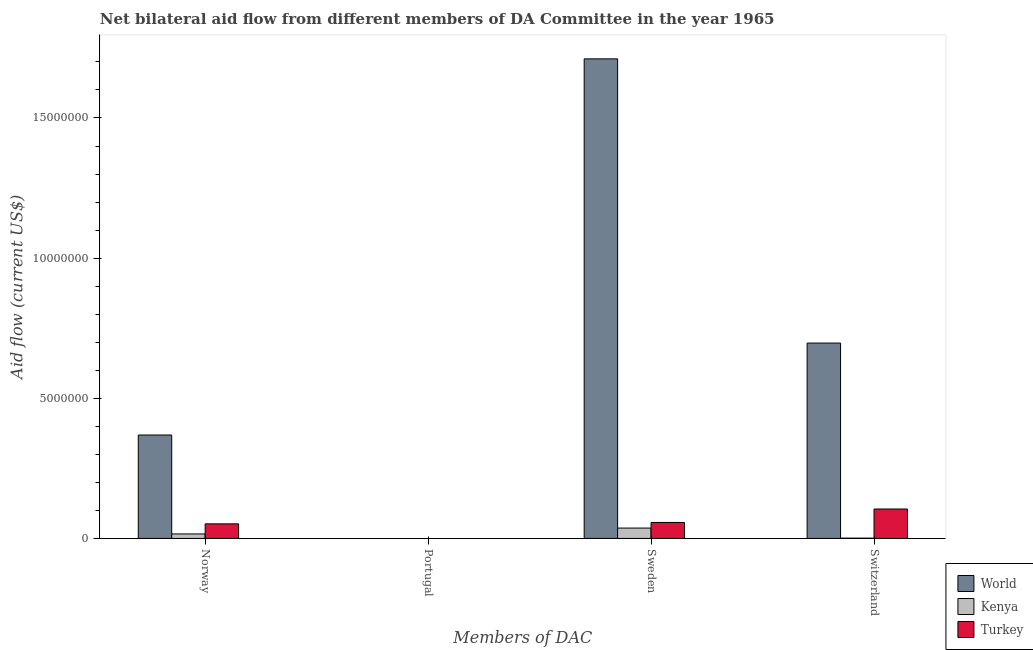How many different coloured bars are there?
Offer a terse response. 3. Are the number of bars per tick equal to the number of legend labels?
Provide a succinct answer. No. How many bars are there on the 1st tick from the left?
Provide a short and direct response. 3. How many bars are there on the 1st tick from the right?
Your response must be concise. 3. What is the label of the 2nd group of bars from the left?
Your answer should be very brief. Portugal. What is the amount of aid given by portugal in World?
Give a very brief answer. 0. Across all countries, what is the maximum amount of aid given by norway?
Your answer should be compact. 3.69e+06. Across all countries, what is the minimum amount of aid given by norway?
Your answer should be very brief. 1.60e+05. What is the total amount of aid given by sweden in the graph?
Offer a terse response. 1.80e+07. What is the difference between the amount of aid given by norway in World and that in Turkey?
Provide a short and direct response. 3.17e+06. What is the difference between the amount of aid given by portugal in Turkey and the amount of aid given by switzerland in World?
Provide a succinct answer. -6.97e+06. What is the average amount of aid given by portugal per country?
Your answer should be very brief. 0. What is the difference between the amount of aid given by norway and amount of aid given by sweden in Turkey?
Your answer should be very brief. -5.00e+04. In how many countries, is the amount of aid given by portugal greater than 9000000 US$?
Offer a terse response. 0. What is the ratio of the amount of aid given by switzerland in Turkey to that in World?
Make the answer very short. 0.15. Is the difference between the amount of aid given by sweden in Kenya and Turkey greater than the difference between the amount of aid given by switzerland in Kenya and Turkey?
Make the answer very short. Yes. What is the difference between the highest and the second highest amount of aid given by norway?
Your answer should be compact. 3.17e+06. What is the difference between the highest and the lowest amount of aid given by norway?
Keep it short and to the point. 3.53e+06. Is it the case that in every country, the sum of the amount of aid given by portugal and amount of aid given by sweden is greater than the sum of amount of aid given by norway and amount of aid given by switzerland?
Make the answer very short. No. How many bars are there?
Offer a very short reply. 12. Are the values on the major ticks of Y-axis written in scientific E-notation?
Provide a short and direct response. No. What is the title of the graph?
Make the answer very short. Net bilateral aid flow from different members of DA Committee in the year 1965. What is the label or title of the X-axis?
Your response must be concise. Members of DAC. What is the Aid flow (current US$) in World in Norway?
Provide a succinct answer. 3.69e+06. What is the Aid flow (current US$) in Turkey in Norway?
Give a very brief answer. 5.20e+05. What is the Aid flow (current US$) in World in Portugal?
Your response must be concise. Nan. What is the Aid flow (current US$) in Kenya in Portugal?
Offer a terse response. Nan. What is the Aid flow (current US$) in Turkey in Portugal?
Your response must be concise. Nan. What is the Aid flow (current US$) in World in Sweden?
Ensure brevity in your answer.  1.71e+07. What is the Aid flow (current US$) in Kenya in Sweden?
Keep it short and to the point. 3.70e+05. What is the Aid flow (current US$) in Turkey in Sweden?
Your answer should be very brief. 5.70e+05. What is the Aid flow (current US$) of World in Switzerland?
Ensure brevity in your answer.  6.97e+06. What is the Aid flow (current US$) of Kenya in Switzerland?
Make the answer very short. 10000. What is the Aid flow (current US$) of Turkey in Switzerland?
Offer a terse response. 1.05e+06. Across all Members of DAC, what is the maximum Aid flow (current US$) of World?
Your answer should be compact. 1.71e+07. Across all Members of DAC, what is the maximum Aid flow (current US$) of Turkey?
Provide a succinct answer. 1.05e+06. Across all Members of DAC, what is the minimum Aid flow (current US$) in World?
Keep it short and to the point. 3.69e+06. Across all Members of DAC, what is the minimum Aid flow (current US$) of Turkey?
Offer a terse response. 5.20e+05. What is the total Aid flow (current US$) in World in the graph?
Offer a terse response. 2.78e+07. What is the total Aid flow (current US$) in Kenya in the graph?
Offer a very short reply. 5.40e+05. What is the total Aid flow (current US$) of Turkey in the graph?
Your answer should be very brief. 2.14e+06. What is the difference between the Aid flow (current US$) in World in Norway and that in Portugal?
Offer a very short reply. Nan. What is the difference between the Aid flow (current US$) in Kenya in Norway and that in Portugal?
Ensure brevity in your answer.  Nan. What is the difference between the Aid flow (current US$) in Turkey in Norway and that in Portugal?
Your response must be concise. Nan. What is the difference between the Aid flow (current US$) in World in Norway and that in Sweden?
Give a very brief answer. -1.34e+07. What is the difference between the Aid flow (current US$) of World in Norway and that in Switzerland?
Offer a terse response. -3.28e+06. What is the difference between the Aid flow (current US$) in Kenya in Norway and that in Switzerland?
Keep it short and to the point. 1.50e+05. What is the difference between the Aid flow (current US$) in Turkey in Norway and that in Switzerland?
Your answer should be compact. -5.30e+05. What is the difference between the Aid flow (current US$) in World in Portugal and that in Sweden?
Give a very brief answer. Nan. What is the difference between the Aid flow (current US$) in Kenya in Portugal and that in Sweden?
Your answer should be very brief. Nan. What is the difference between the Aid flow (current US$) in Turkey in Portugal and that in Sweden?
Offer a terse response. Nan. What is the difference between the Aid flow (current US$) of World in Portugal and that in Switzerland?
Give a very brief answer. Nan. What is the difference between the Aid flow (current US$) of Kenya in Portugal and that in Switzerland?
Offer a very short reply. Nan. What is the difference between the Aid flow (current US$) of Turkey in Portugal and that in Switzerland?
Provide a succinct answer. Nan. What is the difference between the Aid flow (current US$) of World in Sweden and that in Switzerland?
Ensure brevity in your answer.  1.01e+07. What is the difference between the Aid flow (current US$) of Kenya in Sweden and that in Switzerland?
Ensure brevity in your answer.  3.60e+05. What is the difference between the Aid flow (current US$) of Turkey in Sweden and that in Switzerland?
Offer a very short reply. -4.80e+05. What is the difference between the Aid flow (current US$) of World in Norway and the Aid flow (current US$) of Kenya in Portugal?
Offer a very short reply. Nan. What is the difference between the Aid flow (current US$) in World in Norway and the Aid flow (current US$) in Turkey in Portugal?
Ensure brevity in your answer.  Nan. What is the difference between the Aid flow (current US$) of Kenya in Norway and the Aid flow (current US$) of Turkey in Portugal?
Keep it short and to the point. Nan. What is the difference between the Aid flow (current US$) in World in Norway and the Aid flow (current US$) in Kenya in Sweden?
Keep it short and to the point. 3.32e+06. What is the difference between the Aid flow (current US$) of World in Norway and the Aid flow (current US$) of Turkey in Sweden?
Ensure brevity in your answer.  3.12e+06. What is the difference between the Aid flow (current US$) of Kenya in Norway and the Aid flow (current US$) of Turkey in Sweden?
Your answer should be compact. -4.10e+05. What is the difference between the Aid flow (current US$) in World in Norway and the Aid flow (current US$) in Kenya in Switzerland?
Your answer should be compact. 3.68e+06. What is the difference between the Aid flow (current US$) of World in Norway and the Aid flow (current US$) of Turkey in Switzerland?
Offer a very short reply. 2.64e+06. What is the difference between the Aid flow (current US$) of Kenya in Norway and the Aid flow (current US$) of Turkey in Switzerland?
Your answer should be very brief. -8.90e+05. What is the difference between the Aid flow (current US$) in World in Portugal and the Aid flow (current US$) in Kenya in Sweden?
Your response must be concise. Nan. What is the difference between the Aid flow (current US$) in World in Portugal and the Aid flow (current US$) in Turkey in Sweden?
Provide a succinct answer. Nan. What is the difference between the Aid flow (current US$) of Kenya in Portugal and the Aid flow (current US$) of Turkey in Sweden?
Offer a terse response. Nan. What is the difference between the Aid flow (current US$) in World in Portugal and the Aid flow (current US$) in Kenya in Switzerland?
Provide a short and direct response. Nan. What is the difference between the Aid flow (current US$) in World in Portugal and the Aid flow (current US$) in Turkey in Switzerland?
Your answer should be very brief. Nan. What is the difference between the Aid flow (current US$) of Kenya in Portugal and the Aid flow (current US$) of Turkey in Switzerland?
Ensure brevity in your answer.  Nan. What is the difference between the Aid flow (current US$) in World in Sweden and the Aid flow (current US$) in Kenya in Switzerland?
Give a very brief answer. 1.71e+07. What is the difference between the Aid flow (current US$) in World in Sweden and the Aid flow (current US$) in Turkey in Switzerland?
Provide a short and direct response. 1.61e+07. What is the difference between the Aid flow (current US$) of Kenya in Sweden and the Aid flow (current US$) of Turkey in Switzerland?
Keep it short and to the point. -6.80e+05. What is the average Aid flow (current US$) of World per Members of DAC?
Offer a terse response. 6.94e+06. What is the average Aid flow (current US$) of Kenya per Members of DAC?
Offer a terse response. 1.35e+05. What is the average Aid flow (current US$) of Turkey per Members of DAC?
Offer a very short reply. 5.35e+05. What is the difference between the Aid flow (current US$) in World and Aid flow (current US$) in Kenya in Norway?
Ensure brevity in your answer.  3.53e+06. What is the difference between the Aid flow (current US$) of World and Aid flow (current US$) of Turkey in Norway?
Provide a short and direct response. 3.17e+06. What is the difference between the Aid flow (current US$) in Kenya and Aid flow (current US$) in Turkey in Norway?
Your answer should be very brief. -3.60e+05. What is the difference between the Aid flow (current US$) of World and Aid flow (current US$) of Kenya in Portugal?
Give a very brief answer. Nan. What is the difference between the Aid flow (current US$) in World and Aid flow (current US$) in Turkey in Portugal?
Give a very brief answer. Nan. What is the difference between the Aid flow (current US$) in Kenya and Aid flow (current US$) in Turkey in Portugal?
Ensure brevity in your answer.  Nan. What is the difference between the Aid flow (current US$) of World and Aid flow (current US$) of Kenya in Sweden?
Your answer should be compact. 1.67e+07. What is the difference between the Aid flow (current US$) in World and Aid flow (current US$) in Turkey in Sweden?
Provide a succinct answer. 1.65e+07. What is the difference between the Aid flow (current US$) of Kenya and Aid flow (current US$) of Turkey in Sweden?
Ensure brevity in your answer.  -2.00e+05. What is the difference between the Aid flow (current US$) in World and Aid flow (current US$) in Kenya in Switzerland?
Your response must be concise. 6.96e+06. What is the difference between the Aid flow (current US$) of World and Aid flow (current US$) of Turkey in Switzerland?
Provide a succinct answer. 5.92e+06. What is the difference between the Aid flow (current US$) of Kenya and Aid flow (current US$) of Turkey in Switzerland?
Keep it short and to the point. -1.04e+06. What is the ratio of the Aid flow (current US$) in World in Norway to that in Portugal?
Give a very brief answer. Nan. What is the ratio of the Aid flow (current US$) of Kenya in Norway to that in Portugal?
Provide a short and direct response. Nan. What is the ratio of the Aid flow (current US$) in Turkey in Norway to that in Portugal?
Your answer should be compact. Nan. What is the ratio of the Aid flow (current US$) in World in Norway to that in Sweden?
Provide a short and direct response. 0.22. What is the ratio of the Aid flow (current US$) of Kenya in Norway to that in Sweden?
Make the answer very short. 0.43. What is the ratio of the Aid flow (current US$) of Turkey in Norway to that in Sweden?
Offer a terse response. 0.91. What is the ratio of the Aid flow (current US$) in World in Norway to that in Switzerland?
Ensure brevity in your answer.  0.53. What is the ratio of the Aid flow (current US$) of Turkey in Norway to that in Switzerland?
Give a very brief answer. 0.5. What is the ratio of the Aid flow (current US$) of World in Portugal to that in Sweden?
Ensure brevity in your answer.  Nan. What is the ratio of the Aid flow (current US$) in Kenya in Portugal to that in Sweden?
Provide a short and direct response. Nan. What is the ratio of the Aid flow (current US$) in Turkey in Portugal to that in Sweden?
Make the answer very short. Nan. What is the ratio of the Aid flow (current US$) of World in Portugal to that in Switzerland?
Your answer should be very brief. Nan. What is the ratio of the Aid flow (current US$) in Kenya in Portugal to that in Switzerland?
Make the answer very short. Nan. What is the ratio of the Aid flow (current US$) of Turkey in Portugal to that in Switzerland?
Offer a terse response. Nan. What is the ratio of the Aid flow (current US$) of World in Sweden to that in Switzerland?
Your answer should be compact. 2.45. What is the ratio of the Aid flow (current US$) of Turkey in Sweden to that in Switzerland?
Give a very brief answer. 0.54. What is the difference between the highest and the second highest Aid flow (current US$) in World?
Keep it short and to the point. 1.01e+07. What is the difference between the highest and the second highest Aid flow (current US$) in Kenya?
Your response must be concise. 2.10e+05. What is the difference between the highest and the second highest Aid flow (current US$) in Turkey?
Make the answer very short. 4.80e+05. What is the difference between the highest and the lowest Aid flow (current US$) in World?
Ensure brevity in your answer.  1.34e+07. What is the difference between the highest and the lowest Aid flow (current US$) in Turkey?
Keep it short and to the point. 5.30e+05. 